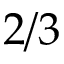<formula> <loc_0><loc_0><loc_500><loc_500>{ 2 / 3 }</formula> 